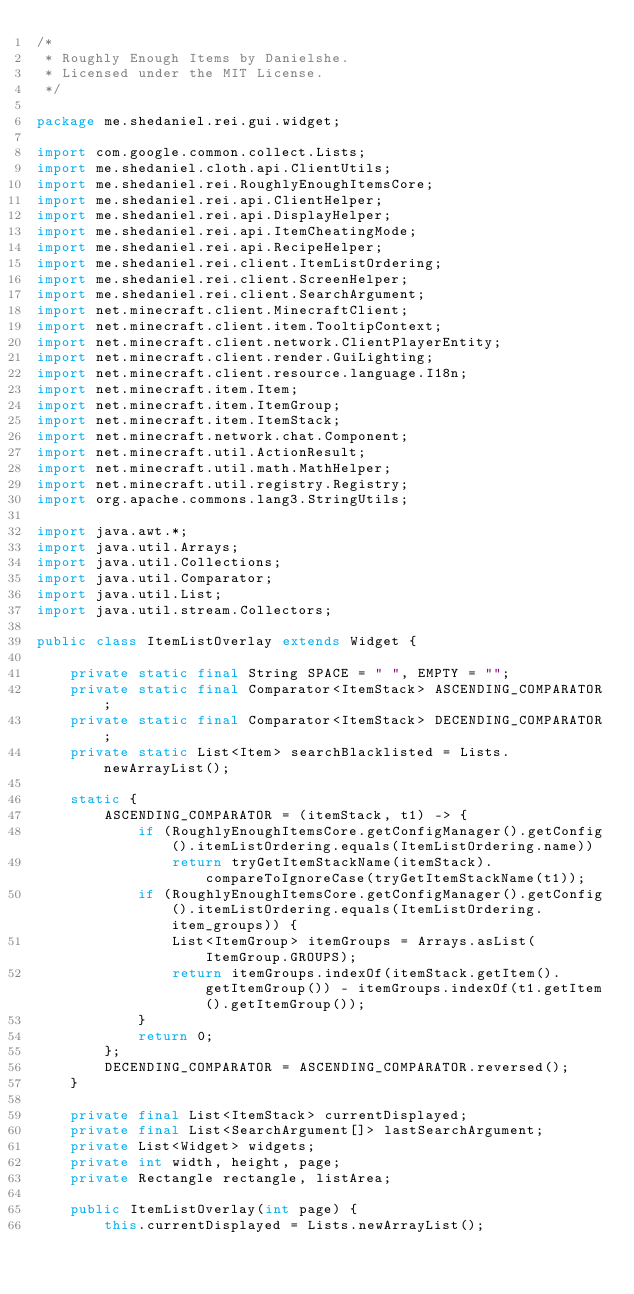Convert code to text. <code><loc_0><loc_0><loc_500><loc_500><_Java_>/*
 * Roughly Enough Items by Danielshe.
 * Licensed under the MIT License.
 */

package me.shedaniel.rei.gui.widget;

import com.google.common.collect.Lists;
import me.shedaniel.cloth.api.ClientUtils;
import me.shedaniel.rei.RoughlyEnoughItemsCore;
import me.shedaniel.rei.api.ClientHelper;
import me.shedaniel.rei.api.DisplayHelper;
import me.shedaniel.rei.api.ItemCheatingMode;
import me.shedaniel.rei.api.RecipeHelper;
import me.shedaniel.rei.client.ItemListOrdering;
import me.shedaniel.rei.client.ScreenHelper;
import me.shedaniel.rei.client.SearchArgument;
import net.minecraft.client.MinecraftClient;
import net.minecraft.client.item.TooltipContext;
import net.minecraft.client.network.ClientPlayerEntity;
import net.minecraft.client.render.GuiLighting;
import net.minecraft.client.resource.language.I18n;
import net.minecraft.item.Item;
import net.minecraft.item.ItemGroup;
import net.minecraft.item.ItemStack;
import net.minecraft.network.chat.Component;
import net.minecraft.util.ActionResult;
import net.minecraft.util.math.MathHelper;
import net.minecraft.util.registry.Registry;
import org.apache.commons.lang3.StringUtils;

import java.awt.*;
import java.util.Arrays;
import java.util.Collections;
import java.util.Comparator;
import java.util.List;
import java.util.stream.Collectors;

public class ItemListOverlay extends Widget {
    
    private static final String SPACE = " ", EMPTY = "";
    private static final Comparator<ItemStack> ASCENDING_COMPARATOR;
    private static final Comparator<ItemStack> DECENDING_COMPARATOR;
    private static List<Item> searchBlacklisted = Lists.newArrayList();
    
    static {
        ASCENDING_COMPARATOR = (itemStack, t1) -> {
            if (RoughlyEnoughItemsCore.getConfigManager().getConfig().itemListOrdering.equals(ItemListOrdering.name))
                return tryGetItemStackName(itemStack).compareToIgnoreCase(tryGetItemStackName(t1));
            if (RoughlyEnoughItemsCore.getConfigManager().getConfig().itemListOrdering.equals(ItemListOrdering.item_groups)) {
                List<ItemGroup> itemGroups = Arrays.asList(ItemGroup.GROUPS);
                return itemGroups.indexOf(itemStack.getItem().getItemGroup()) - itemGroups.indexOf(t1.getItem().getItemGroup());
            }
            return 0;
        };
        DECENDING_COMPARATOR = ASCENDING_COMPARATOR.reversed();
    }
    
    private final List<ItemStack> currentDisplayed;
    private final List<SearchArgument[]> lastSearchArgument;
    private List<Widget> widgets;
    private int width, height, page;
    private Rectangle rectangle, listArea;
    
    public ItemListOverlay(int page) {
        this.currentDisplayed = Lists.newArrayList();</code> 